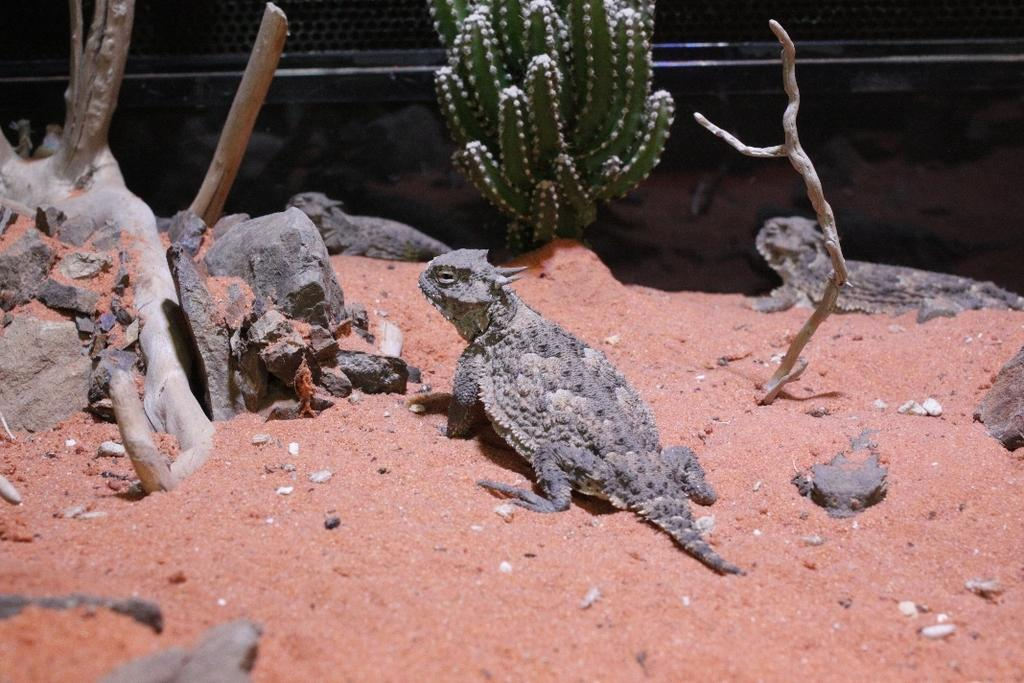What type of animals can be seen on the sand in the image? There are reptiles on the sand in the image. What natural elements are visible in the image? Branches of a tree and a cactus are visible in the image. What type of ground surface is present in the image? There are stones in the image. What can be seen in the background of the image? There is a wall visible in the background of the image. What type of competition is taking place in the image? There is no competition present in the image; it features reptiles on the sand, branches of a tree, stones, a cactus, and a wall in the background. What reward can be seen in the image? There is no reward present in the image. 